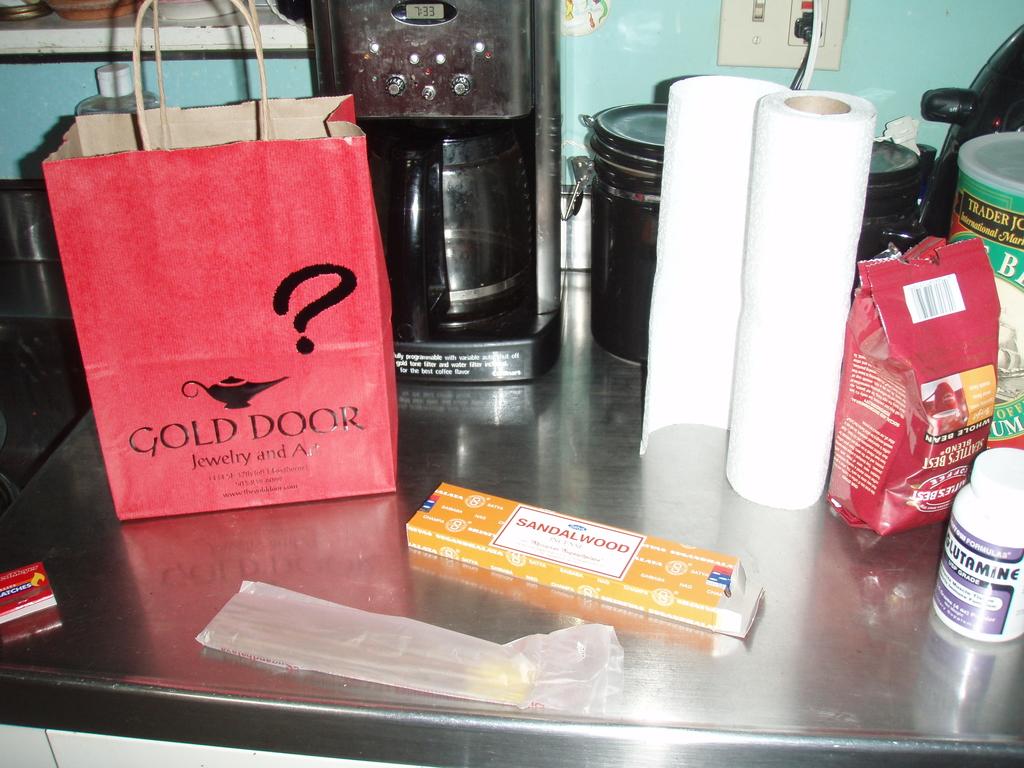What place is the red bag from?
Your answer should be compact. Gold door. What color door is on the bag?
Ensure brevity in your answer.  Gold. 